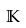<formula> <loc_0><loc_0><loc_500><loc_500>\mathbb { K }</formula> 